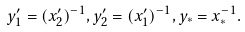<formula> <loc_0><loc_0><loc_500><loc_500>y _ { 1 } ^ { \prime } = ( x _ { 2 } ^ { \prime } ) ^ { - 1 } , y _ { 2 } ^ { \prime } = ( x _ { 1 } ^ { \prime } ) ^ { - 1 } , y _ { \ast } = x _ { \ast } ^ { - 1 } .</formula> 